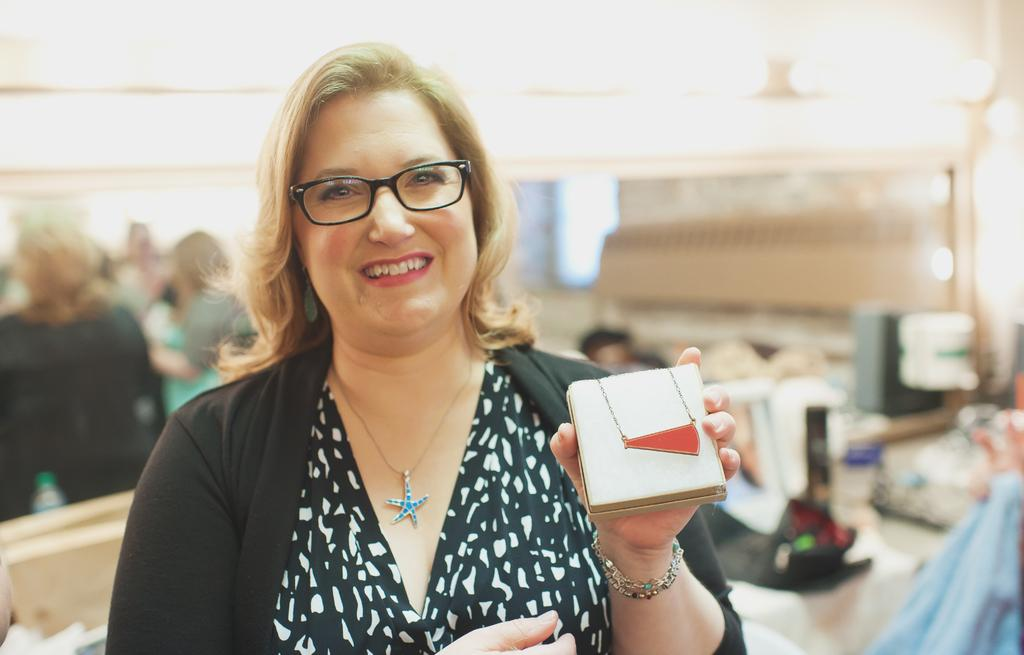Who is the main subject in the image? There is a woman in the image. What is the woman wearing? The woman is wearing a black dress and spectacles. What is the woman's facial expression? The woman is smiling. Can you describe the background of the image? The background of the image is blurred, and there are people visible. What type of skirt is the woman wearing in the image? The woman is not wearing a skirt in the image; she is wearing a black dress. What does the woman wish for in the image? There is no indication in the image that the woman is wishing for anything. 